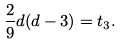Convert formula to latex. <formula><loc_0><loc_0><loc_500><loc_500>\frac { 2 } { 9 } d ( d - 3 ) = t _ { 3 } .</formula> 